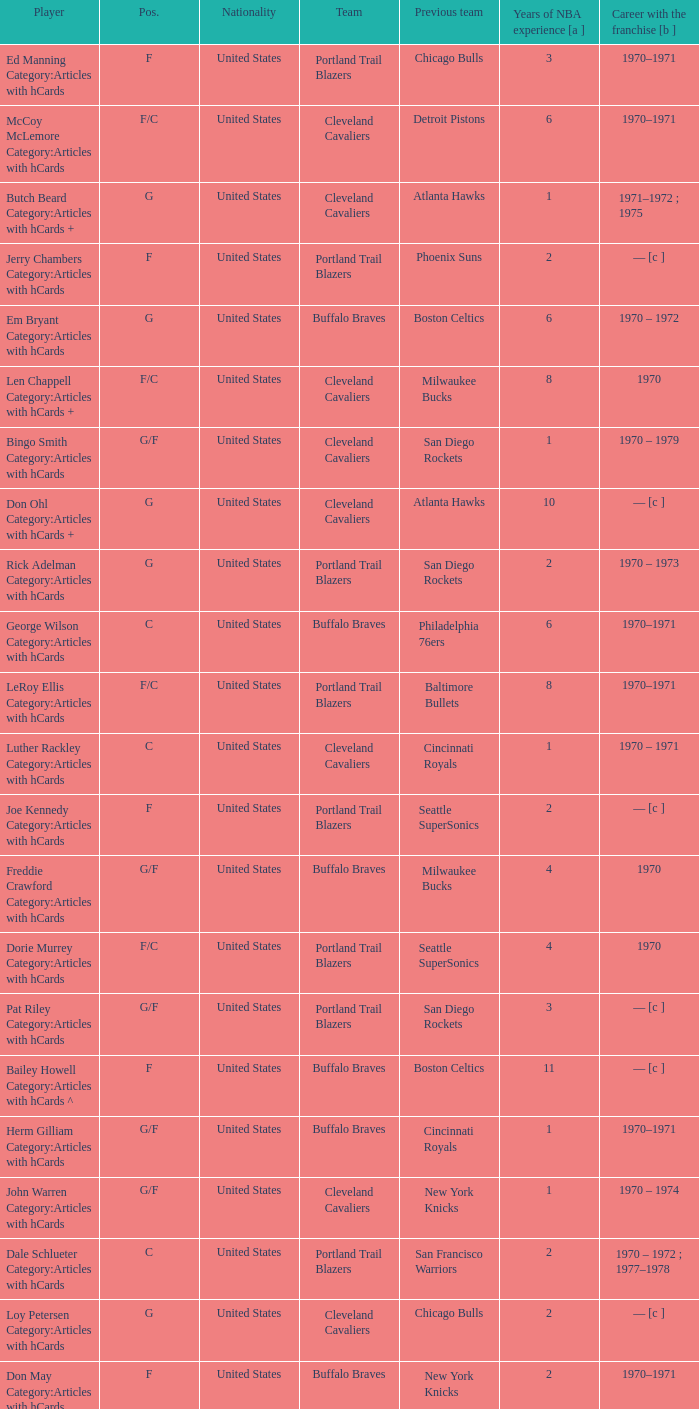How many years of NBA experience does the player who plays position g for the Portland Trail Blazers? 2.0. 